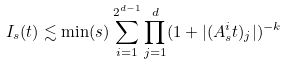Convert formula to latex. <formula><loc_0><loc_0><loc_500><loc_500>I _ { s } ( t ) \lesssim \min ( s ) \sum _ { i = 1 } ^ { 2 ^ { d - 1 } } \prod _ { j = 1 } ^ { d } ( 1 + | ( A ^ { i } _ { s } t ) _ { j } | ) ^ { - k }</formula> 